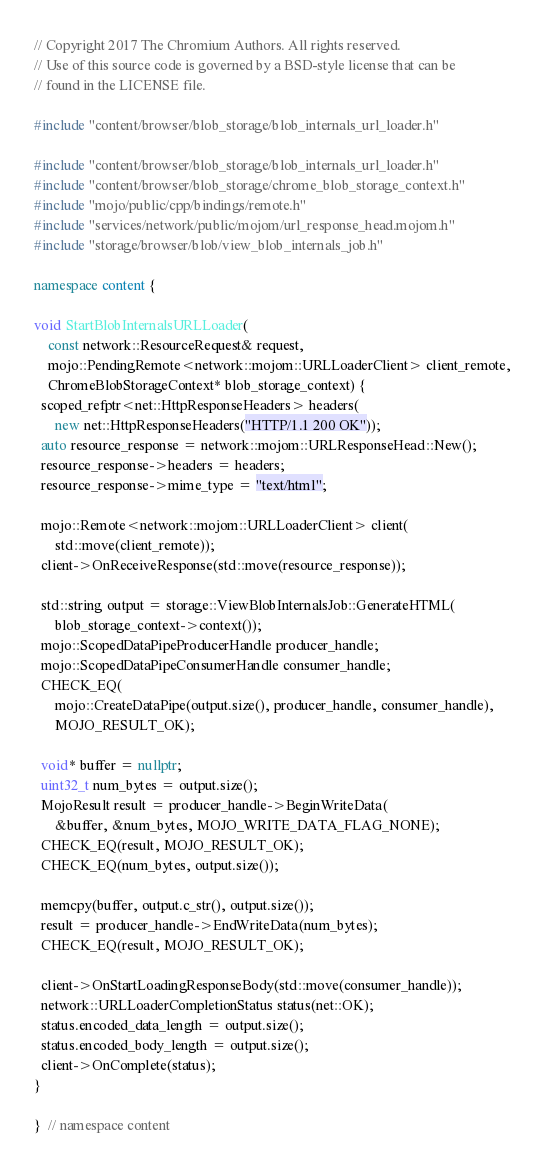<code> <loc_0><loc_0><loc_500><loc_500><_C++_>// Copyright 2017 The Chromium Authors. All rights reserved.
// Use of this source code is governed by a BSD-style license that can be
// found in the LICENSE file.

#include "content/browser/blob_storage/blob_internals_url_loader.h"

#include "content/browser/blob_storage/blob_internals_url_loader.h"
#include "content/browser/blob_storage/chrome_blob_storage_context.h"
#include "mojo/public/cpp/bindings/remote.h"
#include "services/network/public/mojom/url_response_head.mojom.h"
#include "storage/browser/blob/view_blob_internals_job.h"

namespace content {

void StartBlobInternalsURLLoader(
    const network::ResourceRequest& request,
    mojo::PendingRemote<network::mojom::URLLoaderClient> client_remote,
    ChromeBlobStorageContext* blob_storage_context) {
  scoped_refptr<net::HttpResponseHeaders> headers(
      new net::HttpResponseHeaders("HTTP/1.1 200 OK"));
  auto resource_response = network::mojom::URLResponseHead::New();
  resource_response->headers = headers;
  resource_response->mime_type = "text/html";

  mojo::Remote<network::mojom::URLLoaderClient> client(
      std::move(client_remote));
  client->OnReceiveResponse(std::move(resource_response));

  std::string output = storage::ViewBlobInternalsJob::GenerateHTML(
      blob_storage_context->context());
  mojo::ScopedDataPipeProducerHandle producer_handle;
  mojo::ScopedDataPipeConsumerHandle consumer_handle;
  CHECK_EQ(
      mojo::CreateDataPipe(output.size(), producer_handle, consumer_handle),
      MOJO_RESULT_OK);

  void* buffer = nullptr;
  uint32_t num_bytes = output.size();
  MojoResult result = producer_handle->BeginWriteData(
      &buffer, &num_bytes, MOJO_WRITE_DATA_FLAG_NONE);
  CHECK_EQ(result, MOJO_RESULT_OK);
  CHECK_EQ(num_bytes, output.size());

  memcpy(buffer, output.c_str(), output.size());
  result = producer_handle->EndWriteData(num_bytes);
  CHECK_EQ(result, MOJO_RESULT_OK);

  client->OnStartLoadingResponseBody(std::move(consumer_handle));
  network::URLLoaderCompletionStatus status(net::OK);
  status.encoded_data_length = output.size();
  status.encoded_body_length = output.size();
  client->OnComplete(status);
}

}  // namespace content
</code> 